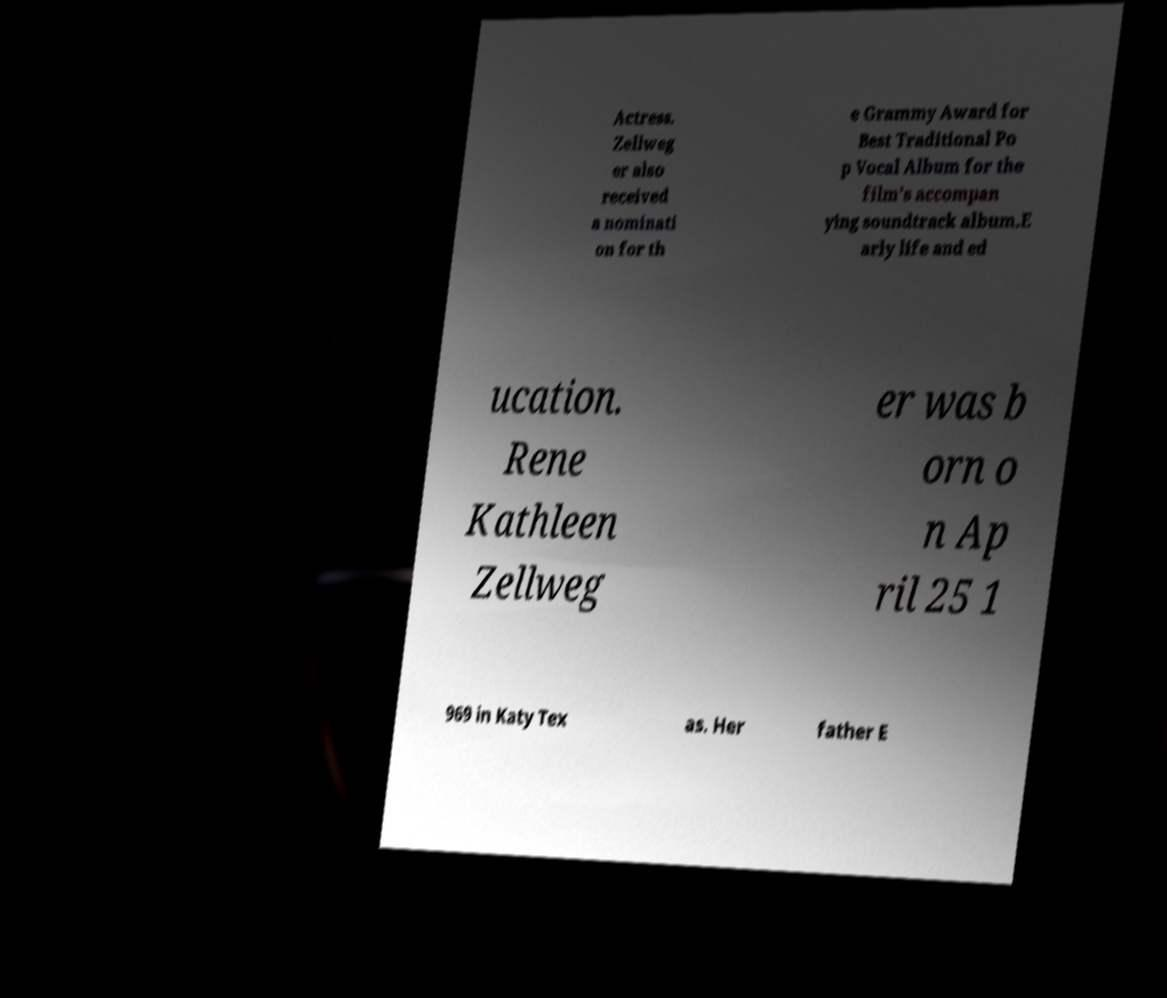I need the written content from this picture converted into text. Can you do that? Actress. Zellweg er also received a nominati on for th e Grammy Award for Best Traditional Po p Vocal Album for the film's accompan ying soundtrack album.E arly life and ed ucation. Rene Kathleen Zellweg er was b orn o n Ap ril 25 1 969 in Katy Tex as. Her father E 